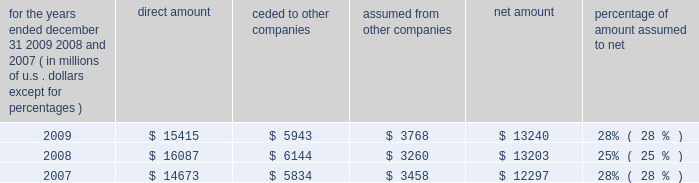S c h e d u l e i v ace limited and subsidiaries s u p p l e m e n t a l i n f o r m a t i o n c o n c e r n i n g r e i n s u r a n c e premiums earned for the years ended december 31 , 2009 , 2008 , and 2007 ( in millions of u.s .
Dollars , except for percentages ) direct amount ceded to companies assumed from other companies net amount percentage of amount assumed to .

What percent of the direct amount is ceded to other companies in 2009 , ( in millions ) ? 
Computations: (5943 / 15415)
Answer: 0.38553. 